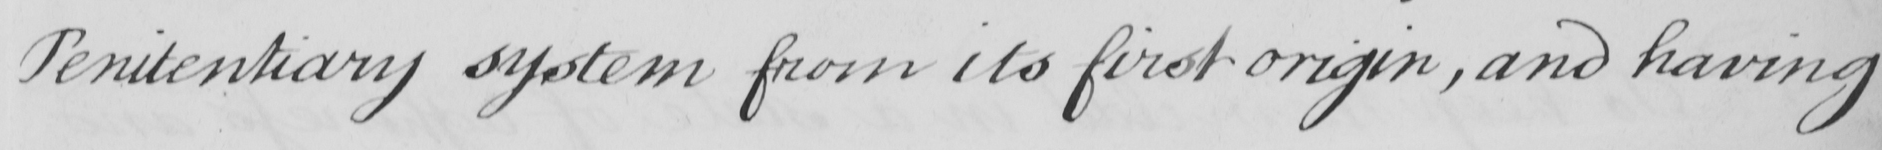What does this handwritten line say? Penitentiary system from its first origin , and having 